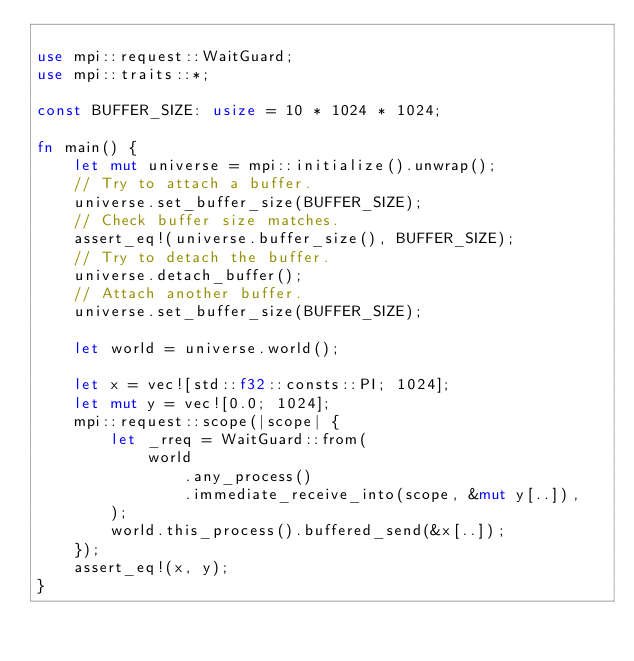Convert code to text. <code><loc_0><loc_0><loc_500><loc_500><_Rust_>
use mpi::request::WaitGuard;
use mpi::traits::*;

const BUFFER_SIZE: usize = 10 * 1024 * 1024;

fn main() {
    let mut universe = mpi::initialize().unwrap();
    // Try to attach a buffer.
    universe.set_buffer_size(BUFFER_SIZE);
    // Check buffer size matches.
    assert_eq!(universe.buffer_size(), BUFFER_SIZE);
    // Try to detach the buffer.
    universe.detach_buffer();
    // Attach another buffer.
    universe.set_buffer_size(BUFFER_SIZE);

    let world = universe.world();

    let x = vec![std::f32::consts::PI; 1024];
    let mut y = vec![0.0; 1024];
    mpi::request::scope(|scope| {
        let _rreq = WaitGuard::from(
            world
                .any_process()
                .immediate_receive_into(scope, &mut y[..]),
        );
        world.this_process().buffered_send(&x[..]);
    });
    assert_eq!(x, y);
}
</code> 